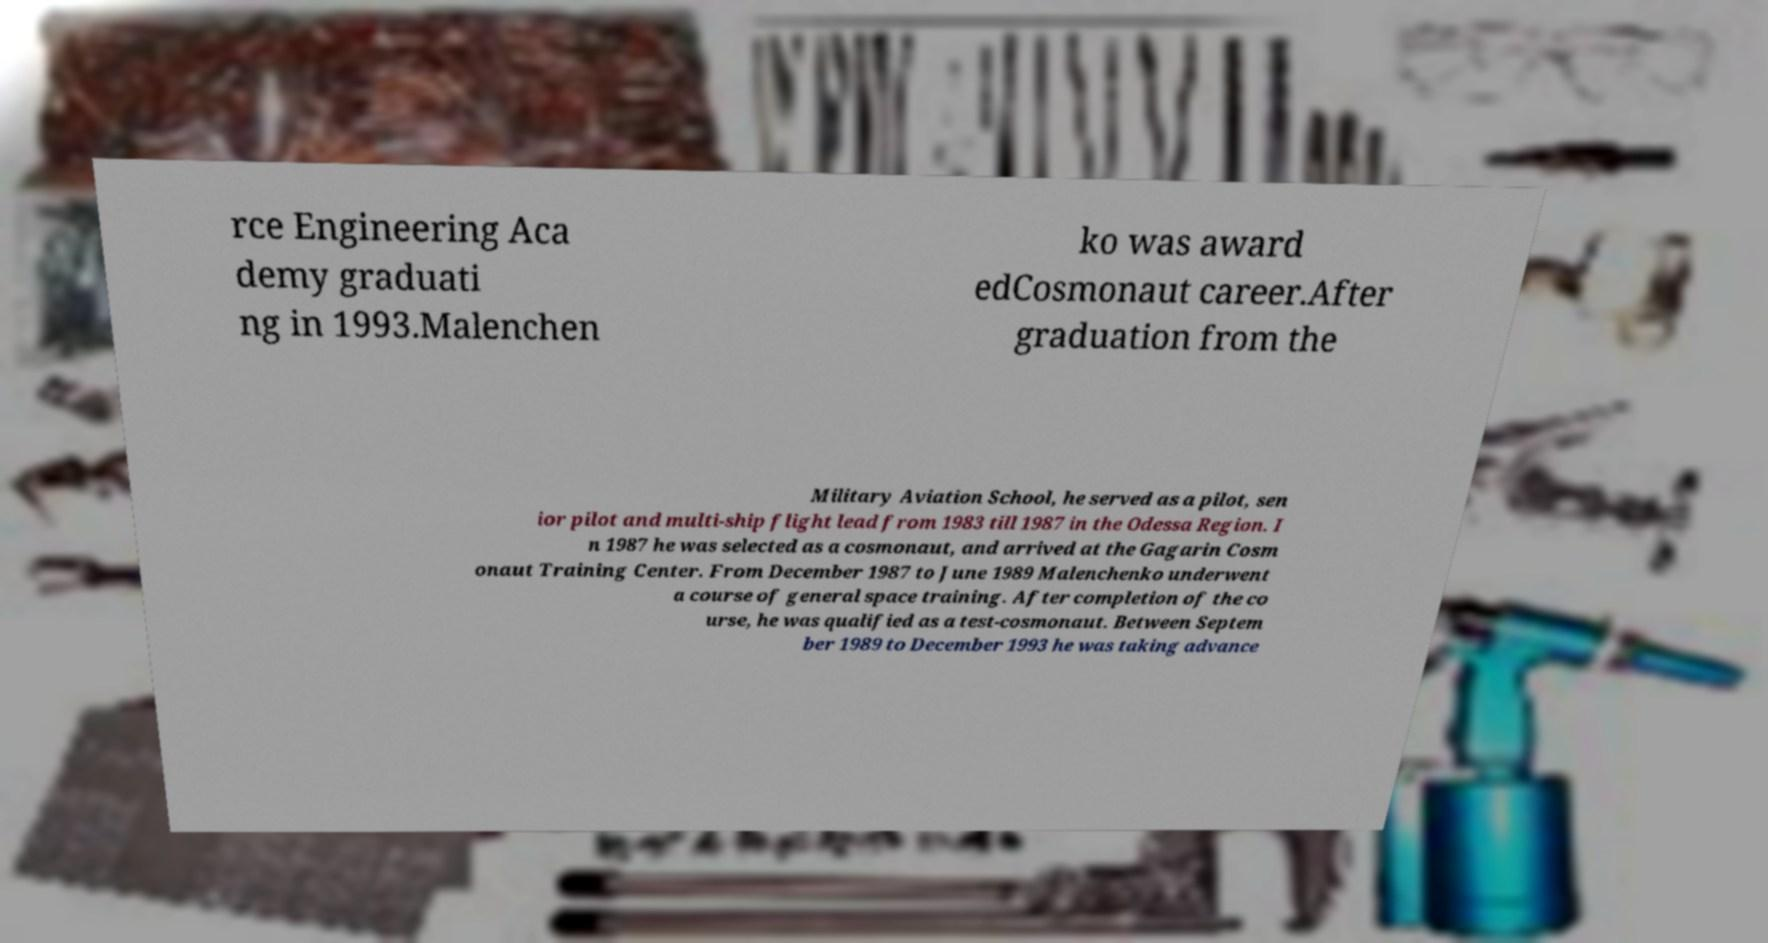Please identify and transcribe the text found in this image. rce Engineering Aca demy graduati ng in 1993.Malenchen ko was award edCosmonaut career.After graduation from the Military Aviation School, he served as a pilot, sen ior pilot and multi-ship flight lead from 1983 till 1987 in the Odessa Region. I n 1987 he was selected as a cosmonaut, and arrived at the Gagarin Cosm onaut Training Center. From December 1987 to June 1989 Malenchenko underwent a course of general space training. After completion of the co urse, he was qualified as a test-cosmonaut. Between Septem ber 1989 to December 1993 he was taking advance 